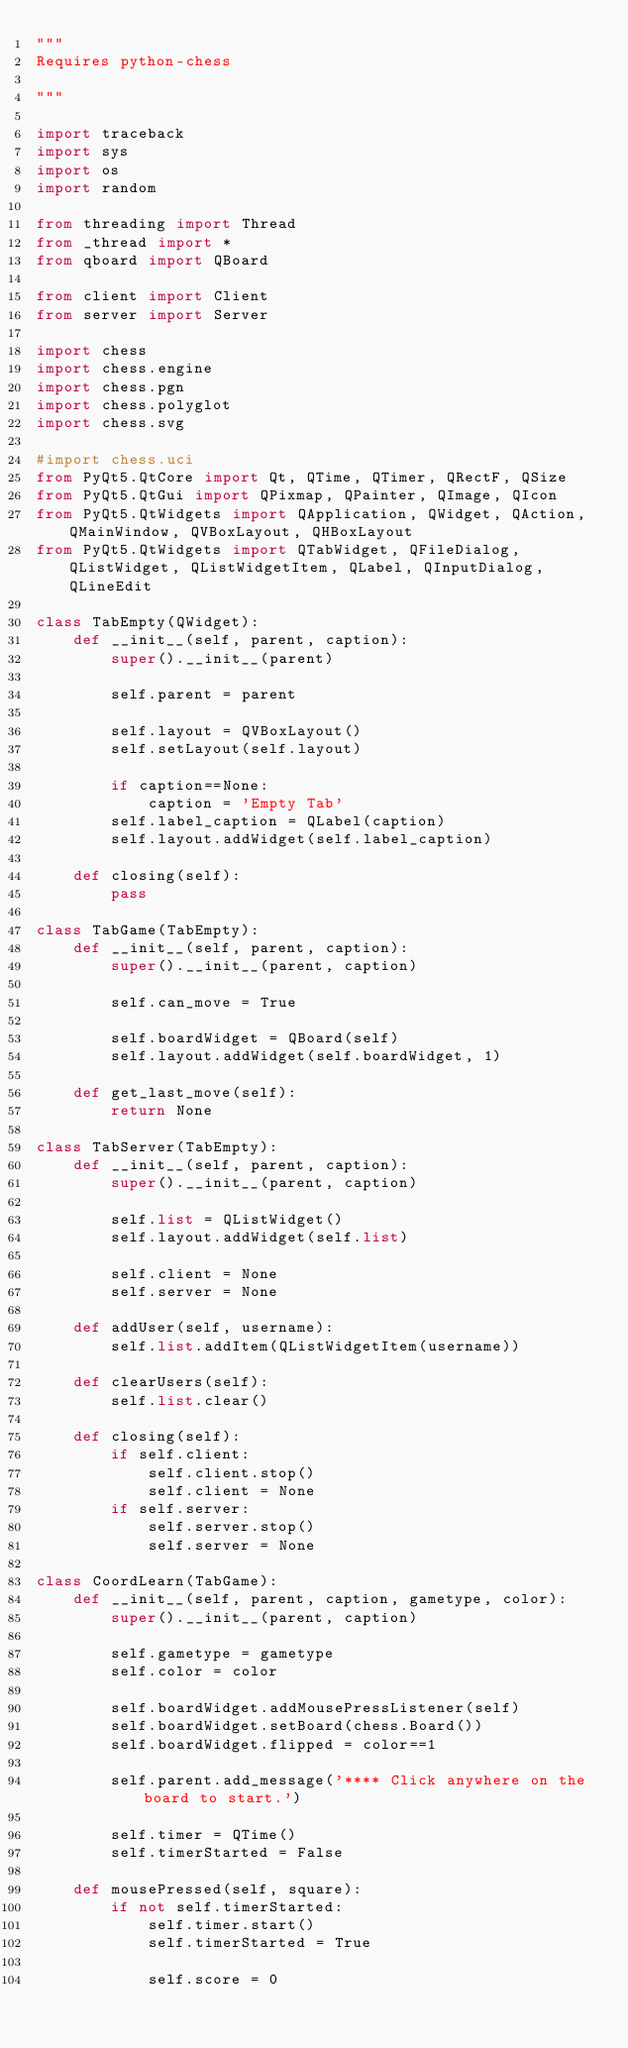<code> <loc_0><loc_0><loc_500><loc_500><_Python_>"""
Requires python-chess

"""

import traceback
import sys
import os
import random

from threading import Thread
from _thread import *
from qboard import QBoard

from client import Client
from server import Server

import chess
import chess.engine
import chess.pgn
import chess.polyglot
import chess.svg

#import chess.uci
from PyQt5.QtCore import Qt, QTime, QTimer, QRectF, QSize
from PyQt5.QtGui import QPixmap, QPainter, QImage, QIcon
from PyQt5.QtWidgets import QApplication, QWidget, QAction, QMainWindow, QVBoxLayout, QHBoxLayout
from PyQt5.QtWidgets import QTabWidget, QFileDialog, QListWidget, QListWidgetItem, QLabel, QInputDialog, QLineEdit

class TabEmpty(QWidget):
    def __init__(self, parent, caption):
        super().__init__(parent)
        
        self.parent = parent
        
        self.layout = QVBoxLayout()
        self.setLayout(self.layout)
        
        if caption==None:
            caption = 'Empty Tab'
        self.label_caption = QLabel(caption)
        self.layout.addWidget(self.label_caption)

    def closing(self):
        pass
        
class TabGame(TabEmpty):
    def __init__(self, parent, caption):
        super().__init__(parent, caption)
        
        self.can_move = True
        
        self.boardWidget = QBoard(self)
        self.layout.addWidget(self.boardWidget, 1)
    
    def get_last_move(self):
        return None
        
class TabServer(TabEmpty):
    def __init__(self, parent, caption):
        super().__init__(parent, caption)
        
        self.list = QListWidget()
        self.layout.addWidget(self.list)
        
        self.client = None
        self.server = None
        
    def addUser(self, username):
        self.list.addItem(QListWidgetItem(username))
    
    def clearUsers(self):
        self.list.clear()
        
    def closing(self):
        if self.client:
            self.client.stop()
            self.client = None
        if self.server:
            self.server.stop()
            self.server = None
            
class CoordLearn(TabGame):
    def __init__(self, parent, caption, gametype, color):
        super().__init__(parent, caption)
        
        self.gametype = gametype
        self.color = color
        
        self.boardWidget.addMousePressListener(self)
        self.boardWidget.setBoard(chess.Board())
        self.boardWidget.flipped = color==1
        
        self.parent.add_message('**** Click anywhere on the board to start.')
        
        self.timer = QTime()
        self.timerStarted = False

    def mousePressed(self, square):
        if not self.timerStarted:
            self.timer.start()
            self.timerStarted = True
            
            self.score = 0
        </code> 